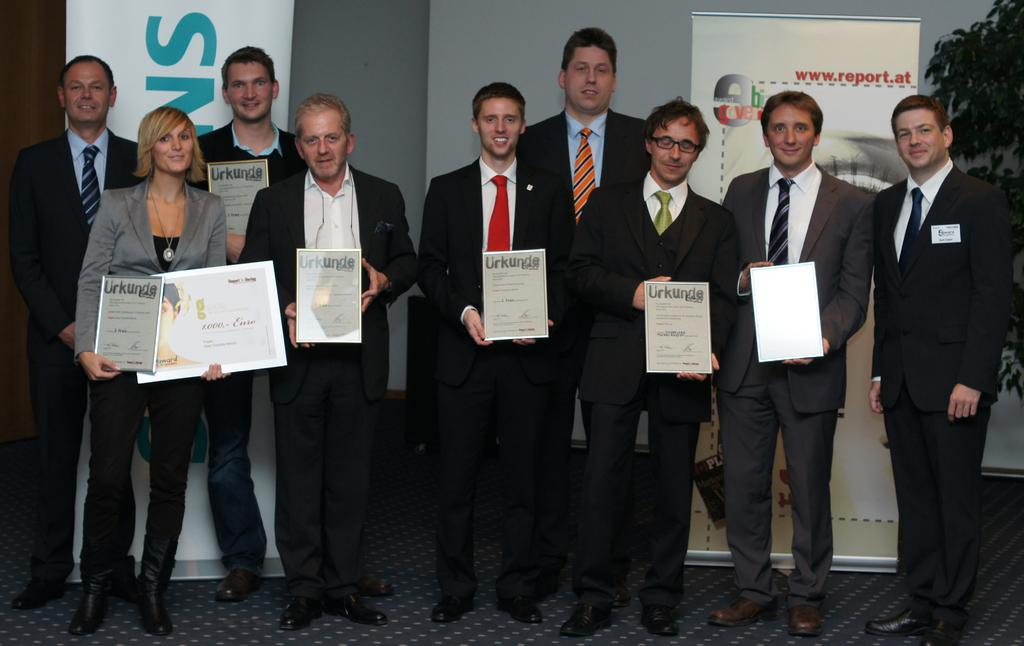What is happening in the image involving the group of people? The people in the image are standing and holding certificates. What can be seen on the certificates? The certificates are not visible in the image, but the people are holding them. What colors are present in the background of the image? There is a white color banner and a gray wall in the background of the image. How much money is being exchanged between the people in the image? There is no indication of money being exchanged in the image; the people are holding certificates. What type of bucket is visible in the image? There is no bucket present in the image. 